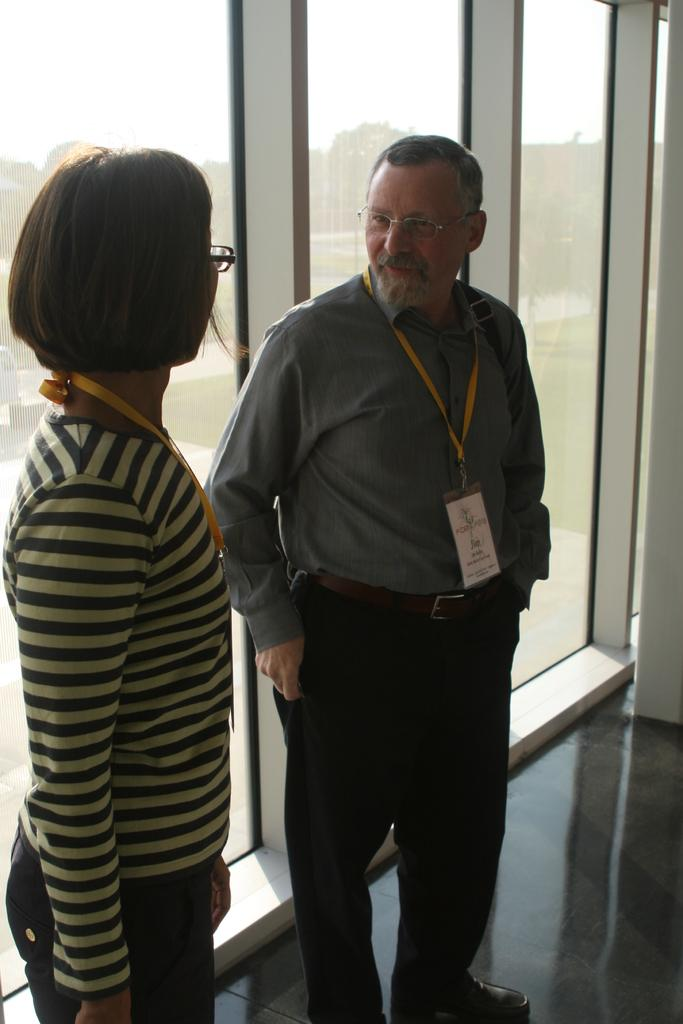What is happening with the two people in the image? The two people are on the floor in the image. What can be seen in the background of the image? There is a glass door in the background of the image, and trees and the sky are visible through it. What type of nation is depicted in the image? There is no nation depicted in the image; it features two people on the floor and a glass door with trees and the sky visible through it. 